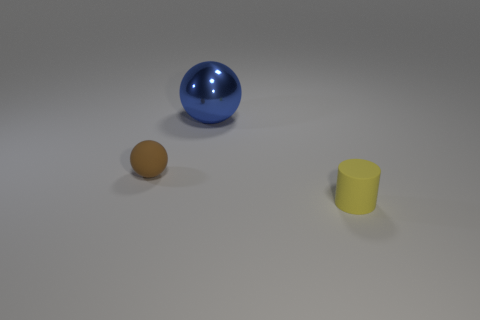Are there more brown spheres that are to the right of the large thing than brown spheres on the right side of the small brown thing?
Your answer should be very brief. No. What is the color of the other large shiny thing that is the same shape as the brown thing?
Offer a very short reply. Blue. Is there any other thing that is the same shape as the blue object?
Make the answer very short. Yes. Do the large metallic object and the matte object that is left of the yellow thing have the same shape?
Make the answer very short. Yes. What number of other objects are the same material as the big sphere?
Ensure brevity in your answer.  0. What is the material of the small object that is on the left side of the yellow rubber object?
Give a very brief answer. Rubber. There is a cylinder that is the same size as the brown matte sphere; what is its color?
Give a very brief answer. Yellow. How many big objects are red matte blocks or blue metallic spheres?
Your response must be concise. 1. Are there an equal number of yellow rubber objects behind the yellow object and blue balls that are right of the small brown matte object?
Your response must be concise. No. How many brown spheres have the same size as the matte cylinder?
Your answer should be very brief. 1. 